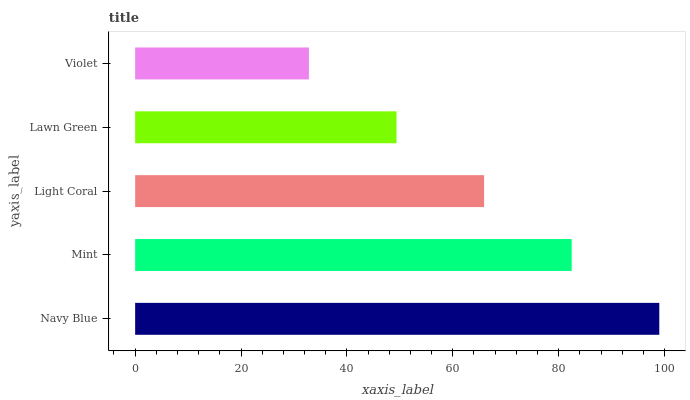Is Violet the minimum?
Answer yes or no. Yes. Is Navy Blue the maximum?
Answer yes or no. Yes. Is Mint the minimum?
Answer yes or no. No. Is Mint the maximum?
Answer yes or no. No. Is Navy Blue greater than Mint?
Answer yes or no. Yes. Is Mint less than Navy Blue?
Answer yes or no. Yes. Is Mint greater than Navy Blue?
Answer yes or no. No. Is Navy Blue less than Mint?
Answer yes or no. No. Is Light Coral the high median?
Answer yes or no. Yes. Is Light Coral the low median?
Answer yes or no. Yes. Is Lawn Green the high median?
Answer yes or no. No. Is Navy Blue the low median?
Answer yes or no. No. 